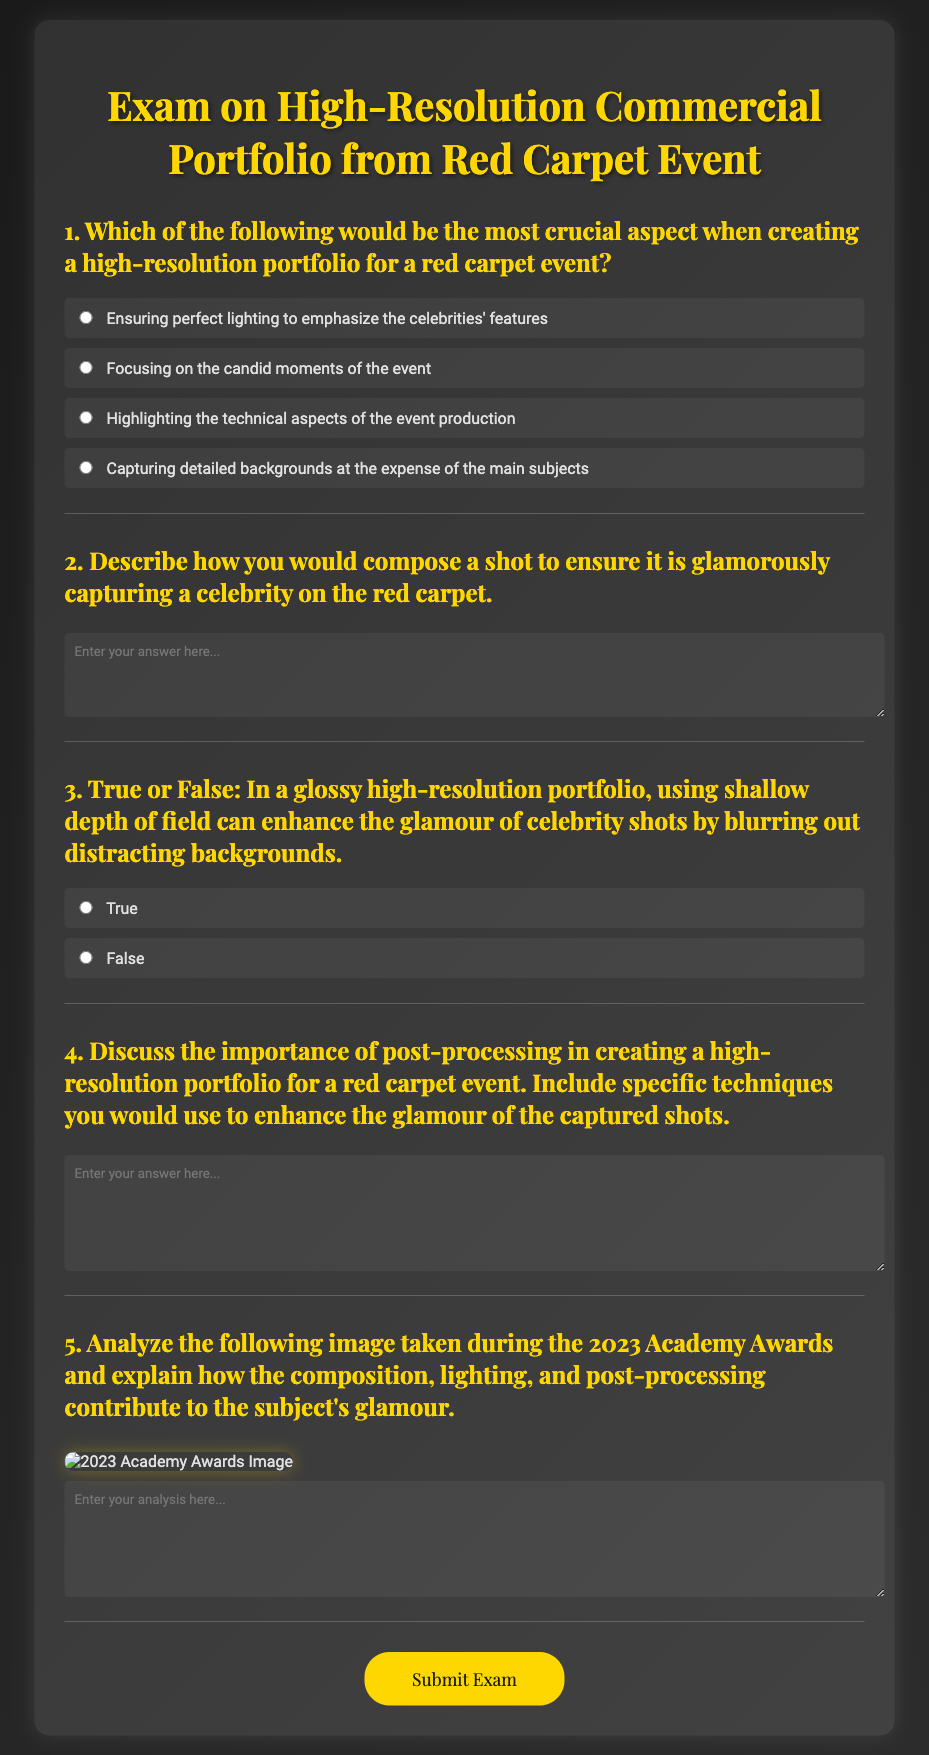What is the title of the document? The title is prominently displayed at the top of the document, which is "Glamorous Red Carpet Portfolio Exam".
Answer: Glamorous Red Carpet Portfolio Exam What is the first question asked in the document? The first question is designed to assess the most crucial aspect of creating a portfolio, which is "Which of the following would be the most crucial aspect when creating a high-resolution portfolio for a red carpet event?"
Answer: Which of the following would be the most crucial aspect when creating a high-resolution portfolio for a red carpet event? How many choices are provided for the first question? The number of choices can be found listed under the first question, which includes four options labeled a, b, c, and d.
Answer: Four What technique is mentioned that can enhance glamour shots? The document states that using shallow depth of field can enhance the glamour of celebrity shots by blurring out distracting backgrounds, which is noted in question 3.
Answer: Shallow depth of field What does the submit button say? The action of submitting the exam is represented by a button, which states "Submit Exam".
Answer: Submit Exam What type of analysis is required for question 5? The fifth question specifically asks for an analysis of an image taken during an event and requires a focus on composition, lighting, and post-processing.
Answer: Analyze the following image taken during the 2023 Academy Awards How many text areas are present for open-ended questions in the document? The document includes three open-ended questions that feature text areas for responses, specifically questions 2, 4, and 5.
Answer: Three What is the background color gradient used in the document? The body of the document has a background gradient that transitions from dark gray to a lighter gray, described as "linear-gradient(135deg, #1a1a1a, #2c2c2c)".
Answer: Dark gray to lighter gray gradient 